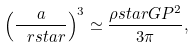<formula> <loc_0><loc_0><loc_500><loc_500>\left ( \frac { a } { \ r s t a r } \right ) ^ { 3 } \simeq \frac { \rho s t a r G P ^ { 2 } } { 3 \pi } ,</formula> 